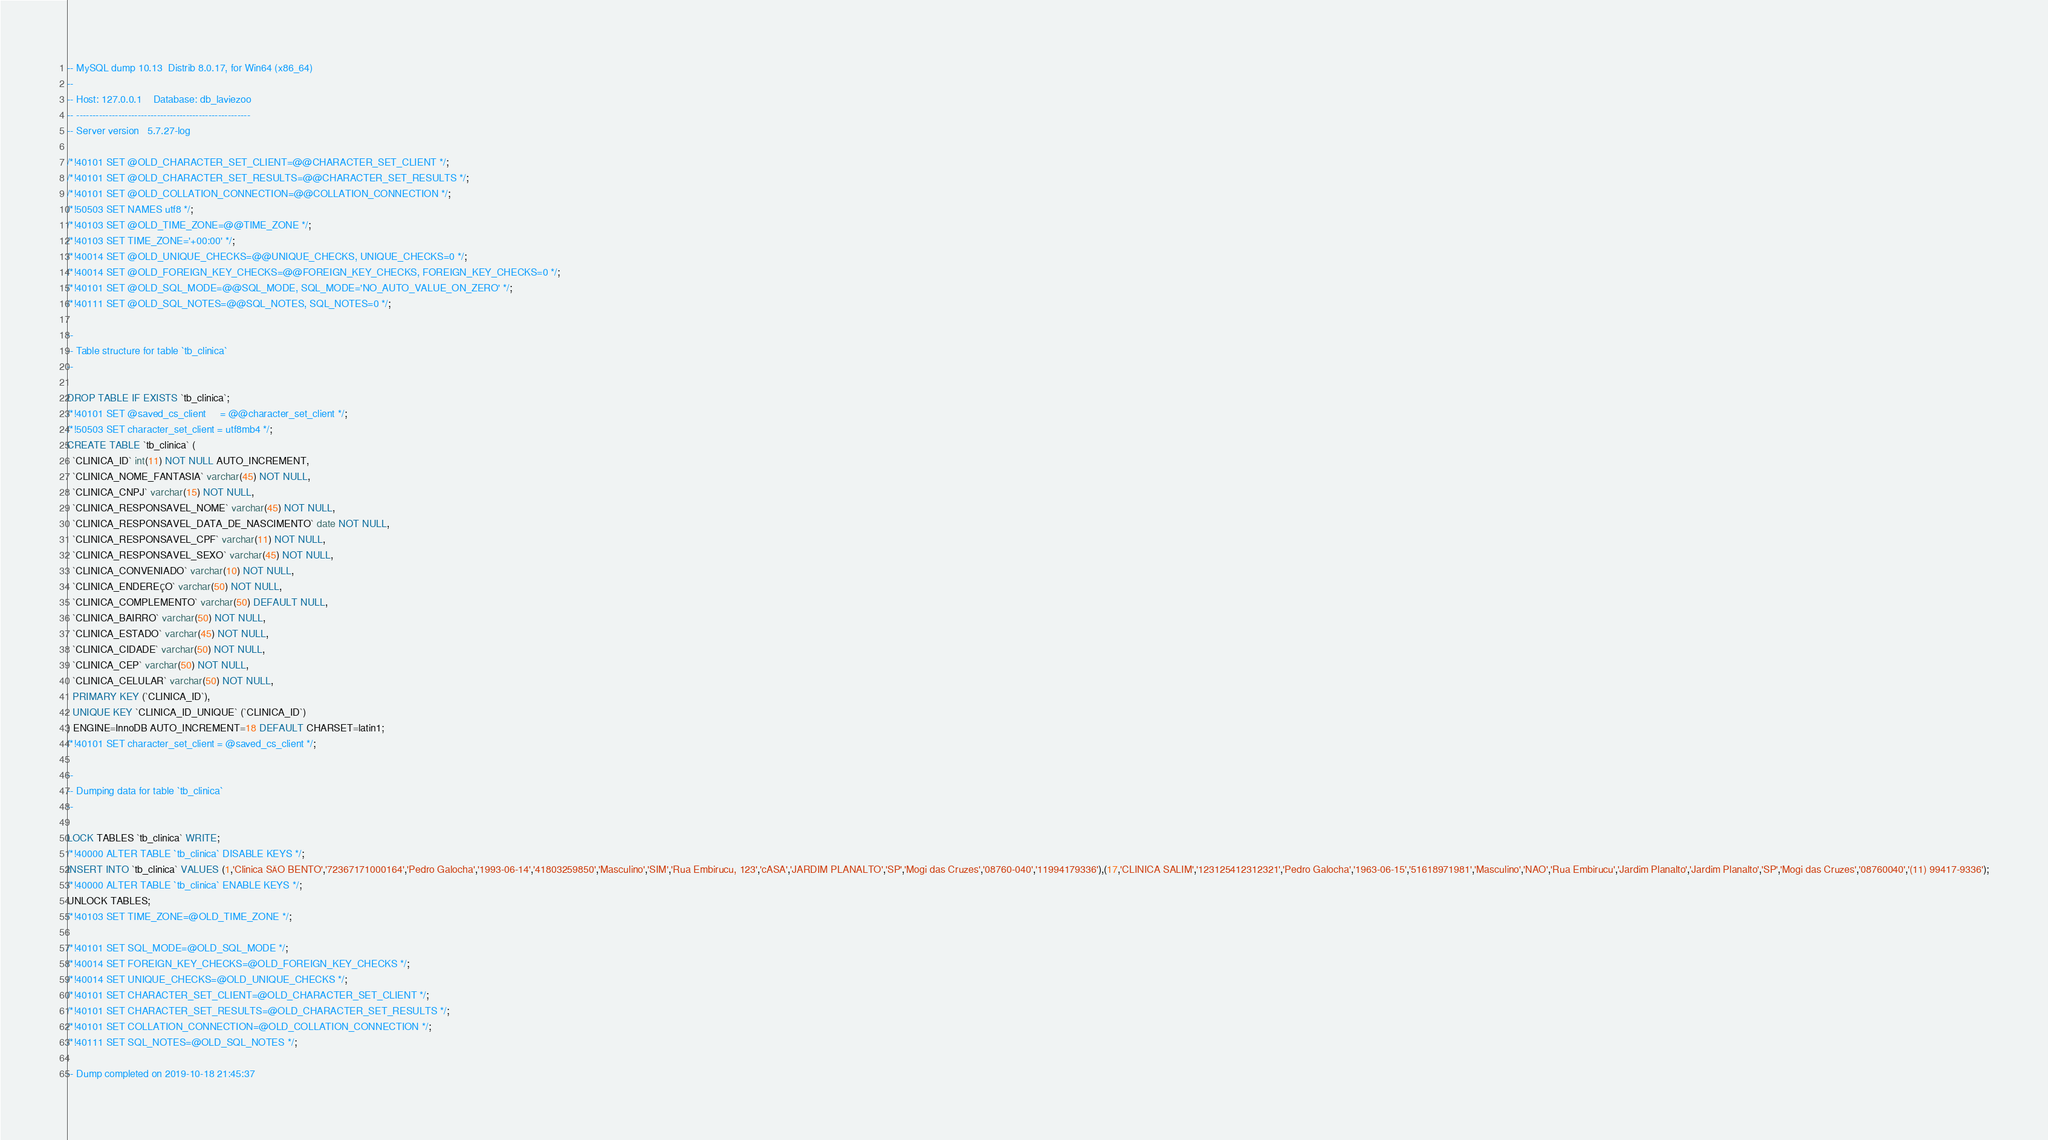<code> <loc_0><loc_0><loc_500><loc_500><_SQL_>-- MySQL dump 10.13  Distrib 8.0.17, for Win64 (x86_64)
--
-- Host: 127.0.0.1    Database: db_laviezoo
-- ------------------------------------------------------
-- Server version	5.7.27-log

/*!40101 SET @OLD_CHARACTER_SET_CLIENT=@@CHARACTER_SET_CLIENT */;
/*!40101 SET @OLD_CHARACTER_SET_RESULTS=@@CHARACTER_SET_RESULTS */;
/*!40101 SET @OLD_COLLATION_CONNECTION=@@COLLATION_CONNECTION */;
/*!50503 SET NAMES utf8 */;
/*!40103 SET @OLD_TIME_ZONE=@@TIME_ZONE */;
/*!40103 SET TIME_ZONE='+00:00' */;
/*!40014 SET @OLD_UNIQUE_CHECKS=@@UNIQUE_CHECKS, UNIQUE_CHECKS=0 */;
/*!40014 SET @OLD_FOREIGN_KEY_CHECKS=@@FOREIGN_KEY_CHECKS, FOREIGN_KEY_CHECKS=0 */;
/*!40101 SET @OLD_SQL_MODE=@@SQL_MODE, SQL_MODE='NO_AUTO_VALUE_ON_ZERO' */;
/*!40111 SET @OLD_SQL_NOTES=@@SQL_NOTES, SQL_NOTES=0 */;

--
-- Table structure for table `tb_clinica`
--

DROP TABLE IF EXISTS `tb_clinica`;
/*!40101 SET @saved_cs_client     = @@character_set_client */;
/*!50503 SET character_set_client = utf8mb4 */;
CREATE TABLE `tb_clinica` (
  `CLINICA_ID` int(11) NOT NULL AUTO_INCREMENT,
  `CLINICA_NOME_FANTASIA` varchar(45) NOT NULL,
  `CLINICA_CNPJ` varchar(15) NOT NULL,
  `CLINICA_RESPONSAVEL_NOME` varchar(45) NOT NULL,
  `CLINICA_RESPONSAVEL_DATA_DE_NASCIMENTO` date NOT NULL,
  `CLINICA_RESPONSAVEL_CPF` varchar(11) NOT NULL,
  `CLINICA_RESPONSAVEL_SEXO` varchar(45) NOT NULL,
  `CLINICA_CONVENIADO` varchar(10) NOT NULL,
  `CLINICA_ENDEREÇO` varchar(50) NOT NULL,
  `CLINICA_COMPLEMENTO` varchar(50) DEFAULT NULL,
  `CLINICA_BAIRRO` varchar(50) NOT NULL,
  `CLINICA_ESTADO` varchar(45) NOT NULL,
  `CLINICA_CIDADE` varchar(50) NOT NULL,
  `CLINICA_CEP` varchar(50) NOT NULL,
  `CLINICA_CELULAR` varchar(50) NOT NULL,
  PRIMARY KEY (`CLINICA_ID`),
  UNIQUE KEY `CLINICA_ID_UNIQUE` (`CLINICA_ID`)
) ENGINE=InnoDB AUTO_INCREMENT=18 DEFAULT CHARSET=latin1;
/*!40101 SET character_set_client = @saved_cs_client */;

--
-- Dumping data for table `tb_clinica`
--

LOCK TABLES `tb_clinica` WRITE;
/*!40000 ALTER TABLE `tb_clinica` DISABLE KEYS */;
INSERT INTO `tb_clinica` VALUES (1,'Clinica SÃO BENTO','72367171000164','Pedro Galocha','1993-06-14','41803259850','Masculino','SIM','Rua Embirucu, 123','cASA','JARDIM PLANALTO','SP','Mogi das Cruzes','08760-040','11994179336'),(17,'CLINICA SALIM','123125412312321','Pedro Galocha','1963-06-15','51618971981','Masculino','NAO','Rua Embirucu','Jardim Planalto','Jardim Planalto','SP','Mogi das Cruzes','08760040','(11) 99417-9336');
/*!40000 ALTER TABLE `tb_clinica` ENABLE KEYS */;
UNLOCK TABLES;
/*!40103 SET TIME_ZONE=@OLD_TIME_ZONE */;

/*!40101 SET SQL_MODE=@OLD_SQL_MODE */;
/*!40014 SET FOREIGN_KEY_CHECKS=@OLD_FOREIGN_KEY_CHECKS */;
/*!40014 SET UNIQUE_CHECKS=@OLD_UNIQUE_CHECKS */;
/*!40101 SET CHARACTER_SET_CLIENT=@OLD_CHARACTER_SET_CLIENT */;
/*!40101 SET CHARACTER_SET_RESULTS=@OLD_CHARACTER_SET_RESULTS */;
/*!40101 SET COLLATION_CONNECTION=@OLD_COLLATION_CONNECTION */;
/*!40111 SET SQL_NOTES=@OLD_SQL_NOTES */;

-- Dump completed on 2019-10-18 21:45:37
</code> 